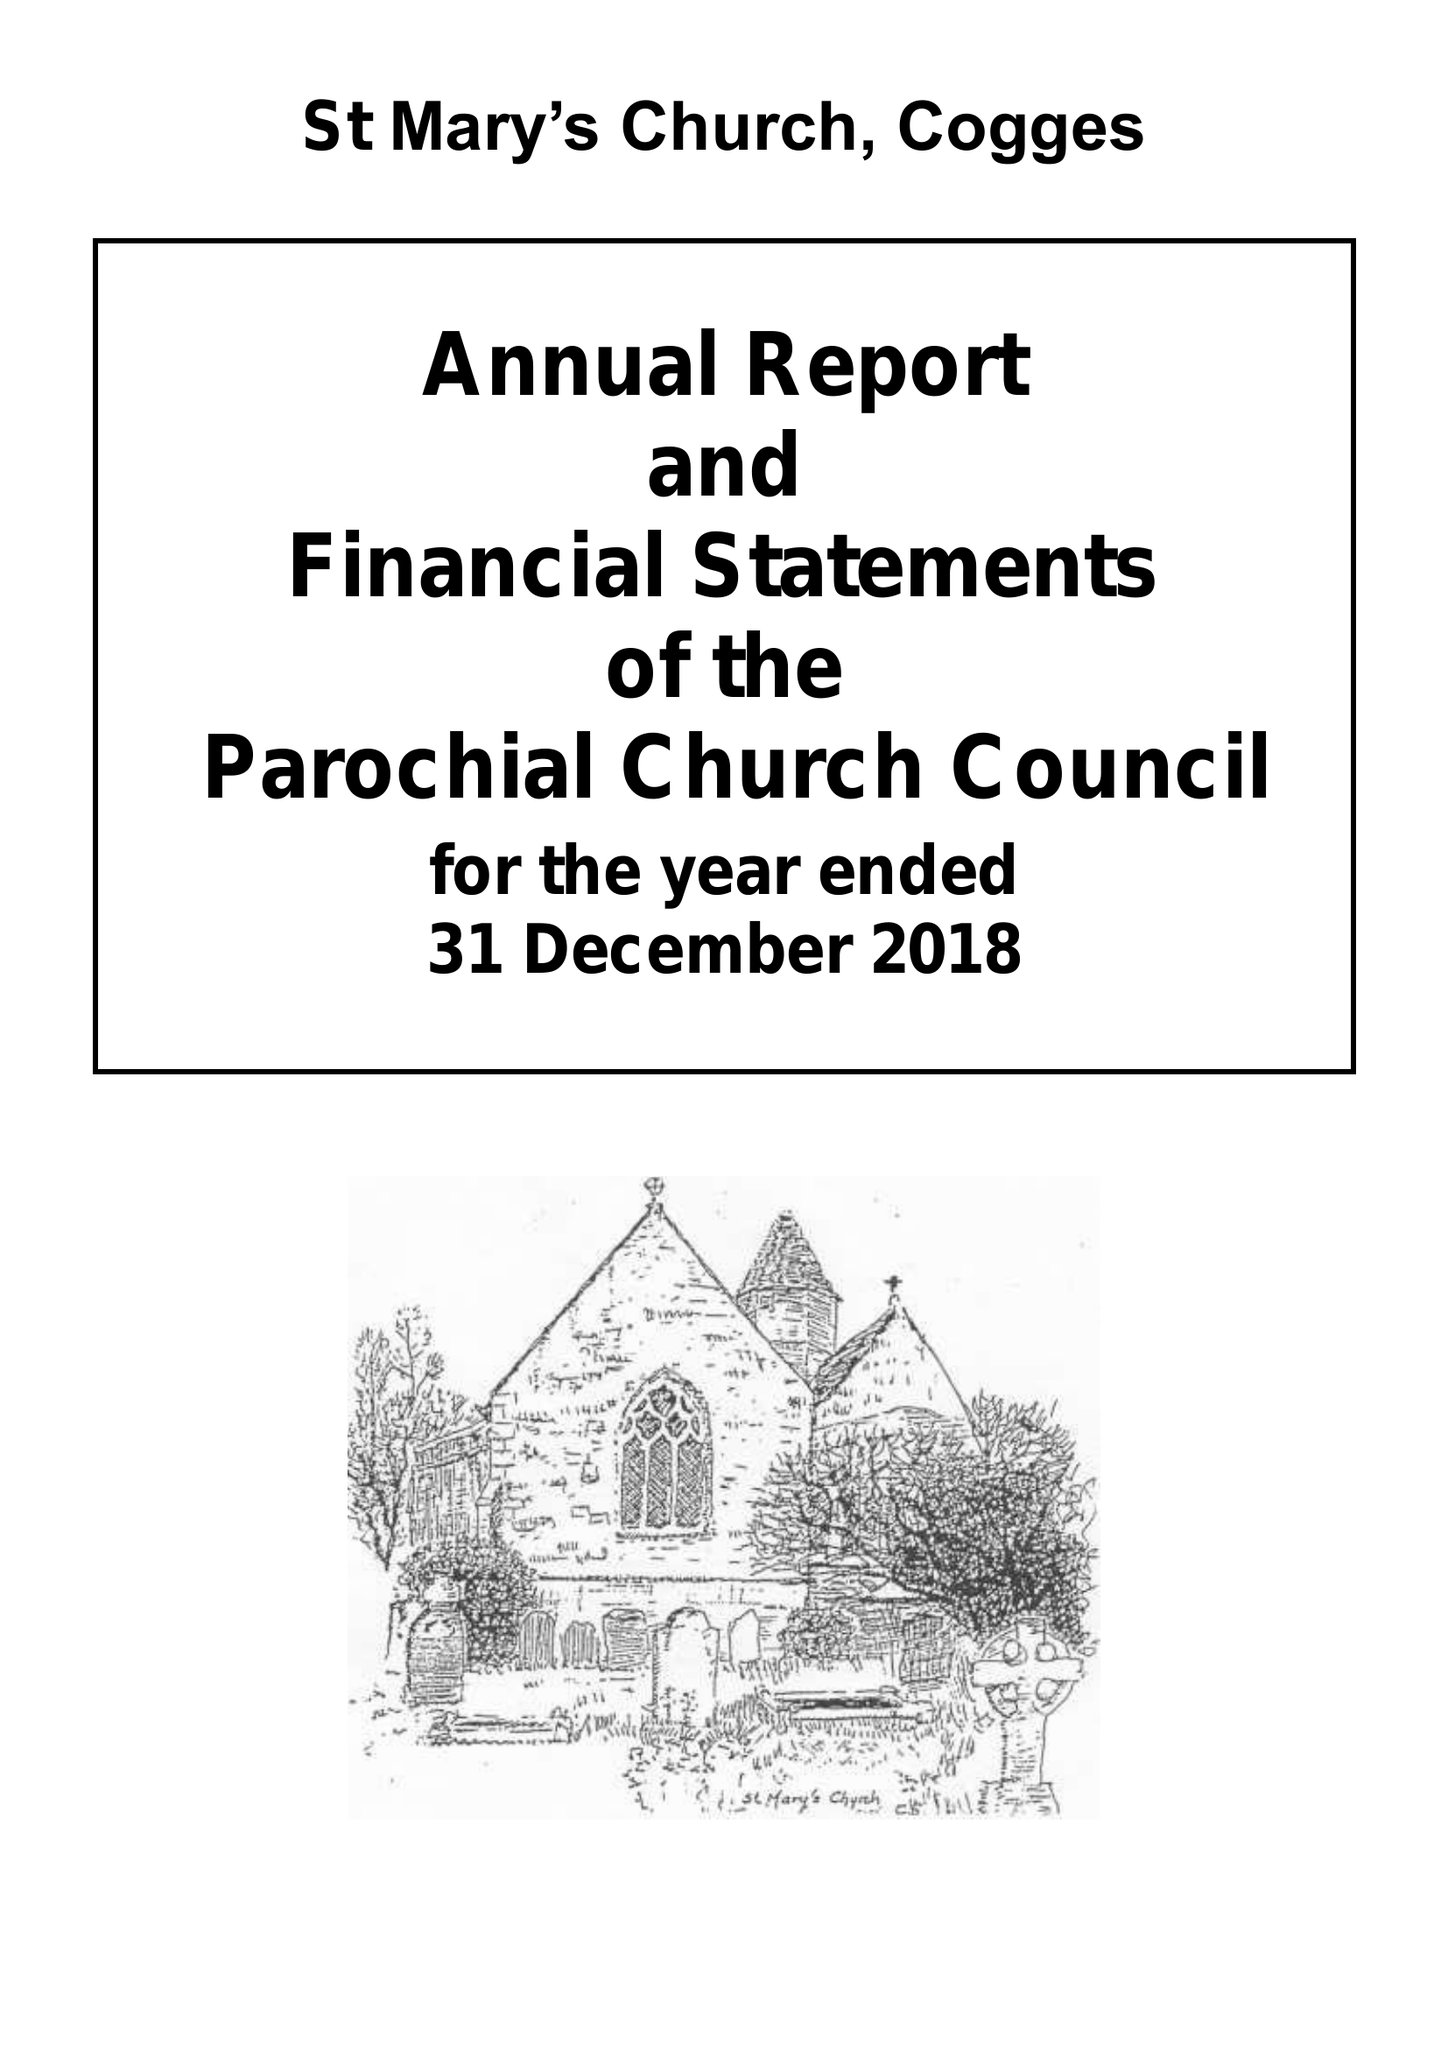What is the value for the income_annually_in_british_pounds?
Answer the question using a single word or phrase. 380299.63 